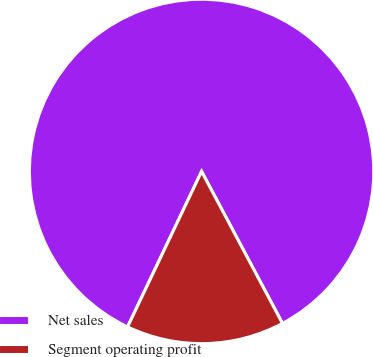<chart> <loc_0><loc_0><loc_500><loc_500><pie_chart><fcel>Net sales<fcel>Segment operating profit<nl><fcel>85.14%<fcel>14.86%<nl></chart> 